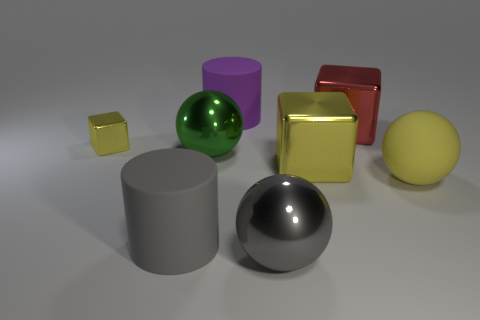Subtract all cyan balls. How many yellow cubes are left? 2 Subtract all yellow metallic cubes. How many cubes are left? 1 Add 1 green spheres. How many objects exist? 9 Subtract all balls. How many objects are left? 5 Add 4 red metal cubes. How many red metal cubes exist? 5 Subtract 0 brown cylinders. How many objects are left? 8 Subtract all rubber balls. Subtract all small blue things. How many objects are left? 7 Add 4 big gray rubber cylinders. How many big gray rubber cylinders are left? 5 